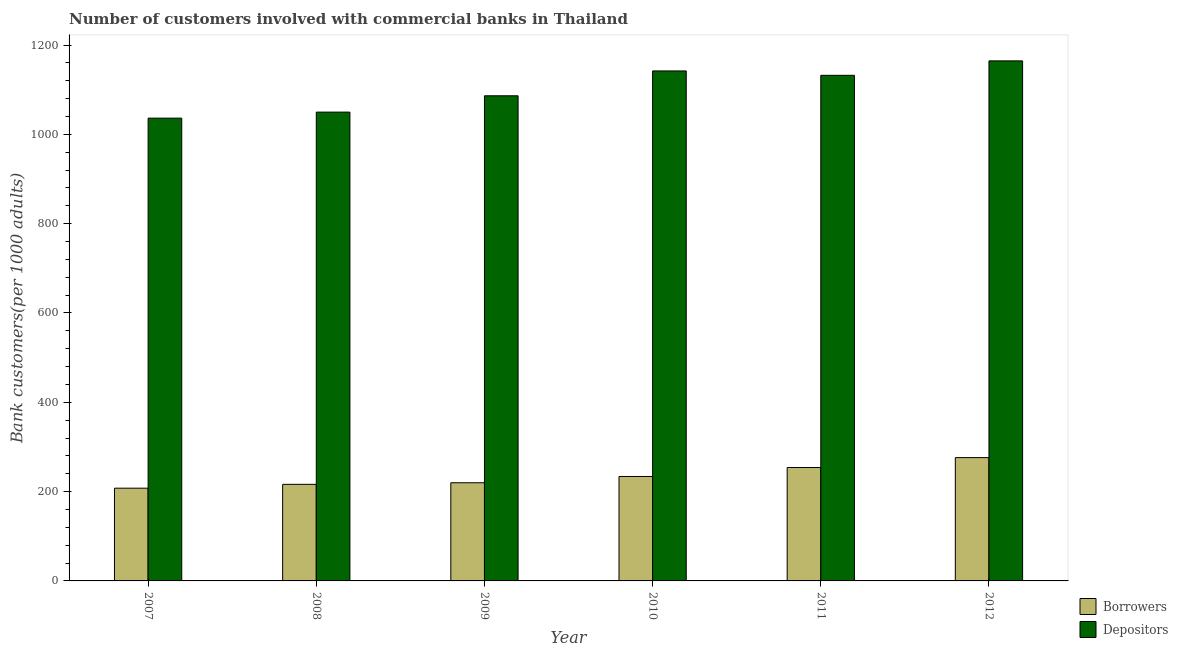How many groups of bars are there?
Keep it short and to the point. 6. Are the number of bars per tick equal to the number of legend labels?
Provide a succinct answer. Yes. In how many cases, is the number of bars for a given year not equal to the number of legend labels?
Keep it short and to the point. 0. What is the number of borrowers in 2011?
Ensure brevity in your answer.  253.97. Across all years, what is the maximum number of borrowers?
Provide a succinct answer. 276.15. Across all years, what is the minimum number of borrowers?
Provide a succinct answer. 207.67. What is the total number of depositors in the graph?
Offer a terse response. 6611.29. What is the difference between the number of borrowers in 2008 and that in 2011?
Your answer should be compact. -37.7. What is the difference between the number of depositors in 2011 and the number of borrowers in 2010?
Offer a very short reply. -9.82. What is the average number of borrowers per year?
Your response must be concise. 234.62. In the year 2007, what is the difference between the number of depositors and number of borrowers?
Offer a very short reply. 0. What is the ratio of the number of borrowers in 2010 to that in 2012?
Your response must be concise. 0.85. What is the difference between the highest and the second highest number of depositors?
Offer a very short reply. 22.53. What is the difference between the highest and the lowest number of borrowers?
Keep it short and to the point. 68.48. Is the sum of the number of borrowers in 2008 and 2012 greater than the maximum number of depositors across all years?
Your answer should be very brief. Yes. What does the 2nd bar from the left in 2011 represents?
Provide a short and direct response. Depositors. What does the 2nd bar from the right in 2011 represents?
Offer a terse response. Borrowers. How many bars are there?
Your response must be concise. 12. How many years are there in the graph?
Provide a succinct answer. 6. What is the difference between two consecutive major ticks on the Y-axis?
Give a very brief answer. 200. Are the values on the major ticks of Y-axis written in scientific E-notation?
Your answer should be compact. No. Does the graph contain grids?
Keep it short and to the point. No. Where does the legend appear in the graph?
Provide a short and direct response. Bottom right. How are the legend labels stacked?
Provide a succinct answer. Vertical. What is the title of the graph?
Your response must be concise. Number of customers involved with commercial banks in Thailand. What is the label or title of the Y-axis?
Your answer should be very brief. Bank customers(per 1000 adults). What is the Bank customers(per 1000 adults) in Borrowers in 2007?
Offer a terse response. 207.67. What is the Bank customers(per 1000 adults) of Depositors in 2007?
Offer a terse response. 1036.31. What is the Bank customers(per 1000 adults) in Borrowers in 2008?
Offer a terse response. 216.28. What is the Bank customers(per 1000 adults) in Depositors in 2008?
Ensure brevity in your answer.  1049.83. What is the Bank customers(per 1000 adults) of Borrowers in 2009?
Your answer should be very brief. 219.81. What is the Bank customers(per 1000 adults) of Depositors in 2009?
Make the answer very short. 1086.36. What is the Bank customers(per 1000 adults) of Borrowers in 2010?
Your answer should be compact. 233.87. What is the Bank customers(per 1000 adults) in Depositors in 2010?
Provide a short and direct response. 1142.03. What is the Bank customers(per 1000 adults) in Borrowers in 2011?
Give a very brief answer. 253.97. What is the Bank customers(per 1000 adults) in Depositors in 2011?
Offer a very short reply. 1132.21. What is the Bank customers(per 1000 adults) in Borrowers in 2012?
Provide a short and direct response. 276.15. What is the Bank customers(per 1000 adults) in Depositors in 2012?
Keep it short and to the point. 1164.56. Across all years, what is the maximum Bank customers(per 1000 adults) in Borrowers?
Your answer should be compact. 276.15. Across all years, what is the maximum Bank customers(per 1000 adults) in Depositors?
Your answer should be very brief. 1164.56. Across all years, what is the minimum Bank customers(per 1000 adults) in Borrowers?
Provide a succinct answer. 207.67. Across all years, what is the minimum Bank customers(per 1000 adults) in Depositors?
Your answer should be very brief. 1036.31. What is the total Bank customers(per 1000 adults) of Borrowers in the graph?
Your response must be concise. 1407.74. What is the total Bank customers(per 1000 adults) in Depositors in the graph?
Your answer should be very brief. 6611.29. What is the difference between the Bank customers(per 1000 adults) in Borrowers in 2007 and that in 2008?
Your answer should be very brief. -8.6. What is the difference between the Bank customers(per 1000 adults) in Depositors in 2007 and that in 2008?
Give a very brief answer. -13.52. What is the difference between the Bank customers(per 1000 adults) of Borrowers in 2007 and that in 2009?
Keep it short and to the point. -12.13. What is the difference between the Bank customers(per 1000 adults) of Depositors in 2007 and that in 2009?
Provide a short and direct response. -50.05. What is the difference between the Bank customers(per 1000 adults) of Borrowers in 2007 and that in 2010?
Ensure brevity in your answer.  -26.2. What is the difference between the Bank customers(per 1000 adults) of Depositors in 2007 and that in 2010?
Keep it short and to the point. -105.72. What is the difference between the Bank customers(per 1000 adults) in Borrowers in 2007 and that in 2011?
Your answer should be compact. -46.3. What is the difference between the Bank customers(per 1000 adults) of Depositors in 2007 and that in 2011?
Provide a succinct answer. -95.9. What is the difference between the Bank customers(per 1000 adults) of Borrowers in 2007 and that in 2012?
Offer a terse response. -68.48. What is the difference between the Bank customers(per 1000 adults) in Depositors in 2007 and that in 2012?
Give a very brief answer. -128.25. What is the difference between the Bank customers(per 1000 adults) of Borrowers in 2008 and that in 2009?
Your answer should be compact. -3.53. What is the difference between the Bank customers(per 1000 adults) of Depositors in 2008 and that in 2009?
Make the answer very short. -36.53. What is the difference between the Bank customers(per 1000 adults) in Borrowers in 2008 and that in 2010?
Your answer should be compact. -17.59. What is the difference between the Bank customers(per 1000 adults) in Depositors in 2008 and that in 2010?
Keep it short and to the point. -92.2. What is the difference between the Bank customers(per 1000 adults) in Borrowers in 2008 and that in 2011?
Your response must be concise. -37.7. What is the difference between the Bank customers(per 1000 adults) of Depositors in 2008 and that in 2011?
Provide a short and direct response. -82.38. What is the difference between the Bank customers(per 1000 adults) in Borrowers in 2008 and that in 2012?
Provide a short and direct response. -59.87. What is the difference between the Bank customers(per 1000 adults) of Depositors in 2008 and that in 2012?
Your answer should be compact. -114.73. What is the difference between the Bank customers(per 1000 adults) of Borrowers in 2009 and that in 2010?
Give a very brief answer. -14.06. What is the difference between the Bank customers(per 1000 adults) in Depositors in 2009 and that in 2010?
Give a very brief answer. -55.66. What is the difference between the Bank customers(per 1000 adults) of Borrowers in 2009 and that in 2011?
Make the answer very short. -34.17. What is the difference between the Bank customers(per 1000 adults) in Depositors in 2009 and that in 2011?
Provide a succinct answer. -45.84. What is the difference between the Bank customers(per 1000 adults) of Borrowers in 2009 and that in 2012?
Ensure brevity in your answer.  -56.34. What is the difference between the Bank customers(per 1000 adults) in Depositors in 2009 and that in 2012?
Make the answer very short. -78.2. What is the difference between the Bank customers(per 1000 adults) in Borrowers in 2010 and that in 2011?
Offer a terse response. -20.1. What is the difference between the Bank customers(per 1000 adults) of Depositors in 2010 and that in 2011?
Offer a very short reply. 9.82. What is the difference between the Bank customers(per 1000 adults) of Borrowers in 2010 and that in 2012?
Offer a very short reply. -42.28. What is the difference between the Bank customers(per 1000 adults) in Depositors in 2010 and that in 2012?
Your answer should be compact. -22.53. What is the difference between the Bank customers(per 1000 adults) in Borrowers in 2011 and that in 2012?
Your answer should be compact. -22.18. What is the difference between the Bank customers(per 1000 adults) of Depositors in 2011 and that in 2012?
Offer a very short reply. -32.35. What is the difference between the Bank customers(per 1000 adults) of Borrowers in 2007 and the Bank customers(per 1000 adults) of Depositors in 2008?
Your answer should be compact. -842.16. What is the difference between the Bank customers(per 1000 adults) in Borrowers in 2007 and the Bank customers(per 1000 adults) in Depositors in 2009?
Provide a succinct answer. -878.69. What is the difference between the Bank customers(per 1000 adults) of Borrowers in 2007 and the Bank customers(per 1000 adults) of Depositors in 2010?
Provide a short and direct response. -934.35. What is the difference between the Bank customers(per 1000 adults) of Borrowers in 2007 and the Bank customers(per 1000 adults) of Depositors in 2011?
Offer a terse response. -924.53. What is the difference between the Bank customers(per 1000 adults) in Borrowers in 2007 and the Bank customers(per 1000 adults) in Depositors in 2012?
Provide a short and direct response. -956.89. What is the difference between the Bank customers(per 1000 adults) in Borrowers in 2008 and the Bank customers(per 1000 adults) in Depositors in 2009?
Your response must be concise. -870.09. What is the difference between the Bank customers(per 1000 adults) of Borrowers in 2008 and the Bank customers(per 1000 adults) of Depositors in 2010?
Your answer should be very brief. -925.75. What is the difference between the Bank customers(per 1000 adults) of Borrowers in 2008 and the Bank customers(per 1000 adults) of Depositors in 2011?
Make the answer very short. -915.93. What is the difference between the Bank customers(per 1000 adults) in Borrowers in 2008 and the Bank customers(per 1000 adults) in Depositors in 2012?
Keep it short and to the point. -948.28. What is the difference between the Bank customers(per 1000 adults) of Borrowers in 2009 and the Bank customers(per 1000 adults) of Depositors in 2010?
Ensure brevity in your answer.  -922.22. What is the difference between the Bank customers(per 1000 adults) of Borrowers in 2009 and the Bank customers(per 1000 adults) of Depositors in 2011?
Your answer should be very brief. -912.4. What is the difference between the Bank customers(per 1000 adults) of Borrowers in 2009 and the Bank customers(per 1000 adults) of Depositors in 2012?
Your answer should be compact. -944.75. What is the difference between the Bank customers(per 1000 adults) in Borrowers in 2010 and the Bank customers(per 1000 adults) in Depositors in 2011?
Give a very brief answer. -898.34. What is the difference between the Bank customers(per 1000 adults) in Borrowers in 2010 and the Bank customers(per 1000 adults) in Depositors in 2012?
Provide a succinct answer. -930.69. What is the difference between the Bank customers(per 1000 adults) of Borrowers in 2011 and the Bank customers(per 1000 adults) of Depositors in 2012?
Make the answer very short. -910.59. What is the average Bank customers(per 1000 adults) in Borrowers per year?
Provide a succinct answer. 234.62. What is the average Bank customers(per 1000 adults) in Depositors per year?
Offer a terse response. 1101.88. In the year 2007, what is the difference between the Bank customers(per 1000 adults) of Borrowers and Bank customers(per 1000 adults) of Depositors?
Your response must be concise. -828.64. In the year 2008, what is the difference between the Bank customers(per 1000 adults) in Borrowers and Bank customers(per 1000 adults) in Depositors?
Your answer should be compact. -833.55. In the year 2009, what is the difference between the Bank customers(per 1000 adults) in Borrowers and Bank customers(per 1000 adults) in Depositors?
Your answer should be compact. -866.56. In the year 2010, what is the difference between the Bank customers(per 1000 adults) of Borrowers and Bank customers(per 1000 adults) of Depositors?
Your response must be concise. -908.16. In the year 2011, what is the difference between the Bank customers(per 1000 adults) of Borrowers and Bank customers(per 1000 adults) of Depositors?
Offer a very short reply. -878.23. In the year 2012, what is the difference between the Bank customers(per 1000 adults) of Borrowers and Bank customers(per 1000 adults) of Depositors?
Your response must be concise. -888.41. What is the ratio of the Bank customers(per 1000 adults) of Borrowers in 2007 to that in 2008?
Your answer should be very brief. 0.96. What is the ratio of the Bank customers(per 1000 adults) of Depositors in 2007 to that in 2008?
Make the answer very short. 0.99. What is the ratio of the Bank customers(per 1000 adults) in Borrowers in 2007 to that in 2009?
Keep it short and to the point. 0.94. What is the ratio of the Bank customers(per 1000 adults) in Depositors in 2007 to that in 2009?
Make the answer very short. 0.95. What is the ratio of the Bank customers(per 1000 adults) of Borrowers in 2007 to that in 2010?
Your answer should be compact. 0.89. What is the ratio of the Bank customers(per 1000 adults) in Depositors in 2007 to that in 2010?
Your answer should be compact. 0.91. What is the ratio of the Bank customers(per 1000 adults) in Borrowers in 2007 to that in 2011?
Give a very brief answer. 0.82. What is the ratio of the Bank customers(per 1000 adults) of Depositors in 2007 to that in 2011?
Your answer should be compact. 0.92. What is the ratio of the Bank customers(per 1000 adults) in Borrowers in 2007 to that in 2012?
Your answer should be compact. 0.75. What is the ratio of the Bank customers(per 1000 adults) in Depositors in 2007 to that in 2012?
Offer a very short reply. 0.89. What is the ratio of the Bank customers(per 1000 adults) in Borrowers in 2008 to that in 2009?
Provide a short and direct response. 0.98. What is the ratio of the Bank customers(per 1000 adults) of Depositors in 2008 to that in 2009?
Your answer should be very brief. 0.97. What is the ratio of the Bank customers(per 1000 adults) of Borrowers in 2008 to that in 2010?
Give a very brief answer. 0.92. What is the ratio of the Bank customers(per 1000 adults) in Depositors in 2008 to that in 2010?
Make the answer very short. 0.92. What is the ratio of the Bank customers(per 1000 adults) of Borrowers in 2008 to that in 2011?
Offer a terse response. 0.85. What is the ratio of the Bank customers(per 1000 adults) in Depositors in 2008 to that in 2011?
Your answer should be compact. 0.93. What is the ratio of the Bank customers(per 1000 adults) in Borrowers in 2008 to that in 2012?
Offer a very short reply. 0.78. What is the ratio of the Bank customers(per 1000 adults) of Depositors in 2008 to that in 2012?
Keep it short and to the point. 0.9. What is the ratio of the Bank customers(per 1000 adults) in Borrowers in 2009 to that in 2010?
Keep it short and to the point. 0.94. What is the ratio of the Bank customers(per 1000 adults) of Depositors in 2009 to that in 2010?
Provide a succinct answer. 0.95. What is the ratio of the Bank customers(per 1000 adults) of Borrowers in 2009 to that in 2011?
Give a very brief answer. 0.87. What is the ratio of the Bank customers(per 1000 adults) in Depositors in 2009 to that in 2011?
Offer a very short reply. 0.96. What is the ratio of the Bank customers(per 1000 adults) in Borrowers in 2009 to that in 2012?
Your answer should be compact. 0.8. What is the ratio of the Bank customers(per 1000 adults) in Depositors in 2009 to that in 2012?
Make the answer very short. 0.93. What is the ratio of the Bank customers(per 1000 adults) of Borrowers in 2010 to that in 2011?
Ensure brevity in your answer.  0.92. What is the ratio of the Bank customers(per 1000 adults) in Depositors in 2010 to that in 2011?
Keep it short and to the point. 1.01. What is the ratio of the Bank customers(per 1000 adults) of Borrowers in 2010 to that in 2012?
Keep it short and to the point. 0.85. What is the ratio of the Bank customers(per 1000 adults) in Depositors in 2010 to that in 2012?
Offer a very short reply. 0.98. What is the ratio of the Bank customers(per 1000 adults) in Borrowers in 2011 to that in 2012?
Provide a succinct answer. 0.92. What is the ratio of the Bank customers(per 1000 adults) of Depositors in 2011 to that in 2012?
Make the answer very short. 0.97. What is the difference between the highest and the second highest Bank customers(per 1000 adults) in Borrowers?
Keep it short and to the point. 22.18. What is the difference between the highest and the second highest Bank customers(per 1000 adults) of Depositors?
Your response must be concise. 22.53. What is the difference between the highest and the lowest Bank customers(per 1000 adults) in Borrowers?
Offer a terse response. 68.48. What is the difference between the highest and the lowest Bank customers(per 1000 adults) of Depositors?
Offer a terse response. 128.25. 